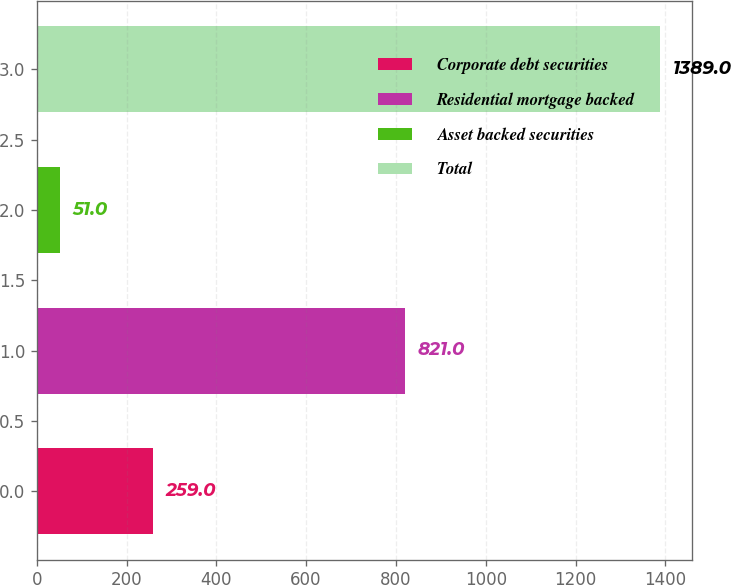Convert chart to OTSL. <chart><loc_0><loc_0><loc_500><loc_500><bar_chart><fcel>Corporate debt securities<fcel>Residential mortgage backed<fcel>Asset backed securities<fcel>Total<nl><fcel>259<fcel>821<fcel>51<fcel>1389<nl></chart> 